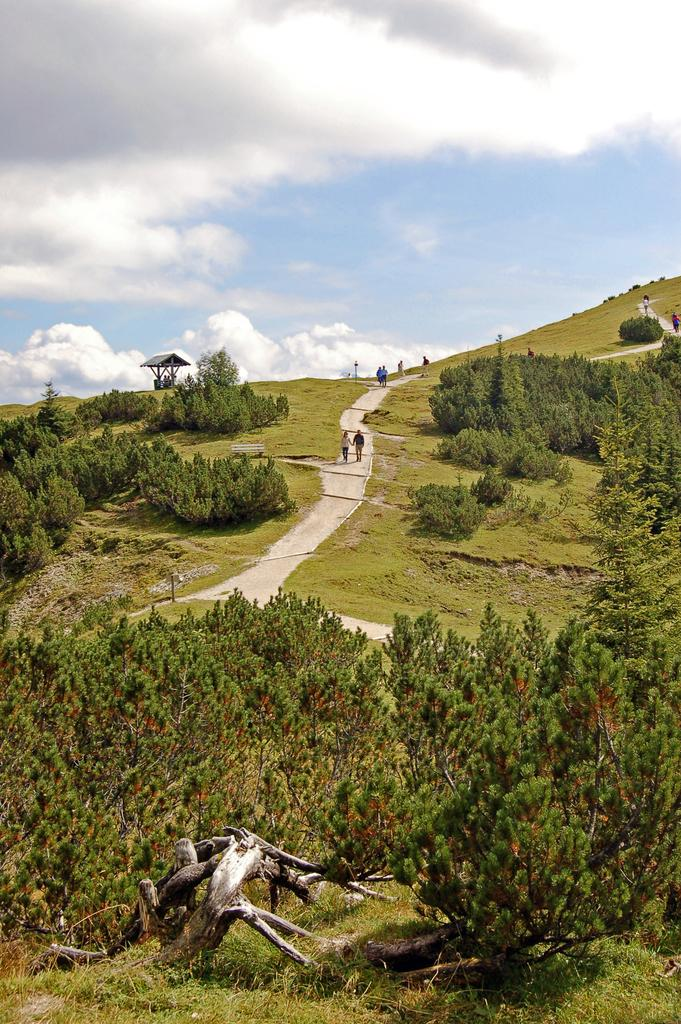What can be seen in the background of the image? The area in the image is surrounded by greenery. What feature allows people to walk through the grass? There is a path through the grass in the image. What are the people in the image doing? There are people walking on the path in the image. What type of mouth can be seen on the squirrel in the image? There is no squirrel present in the image, so there is no mouth to observe. 